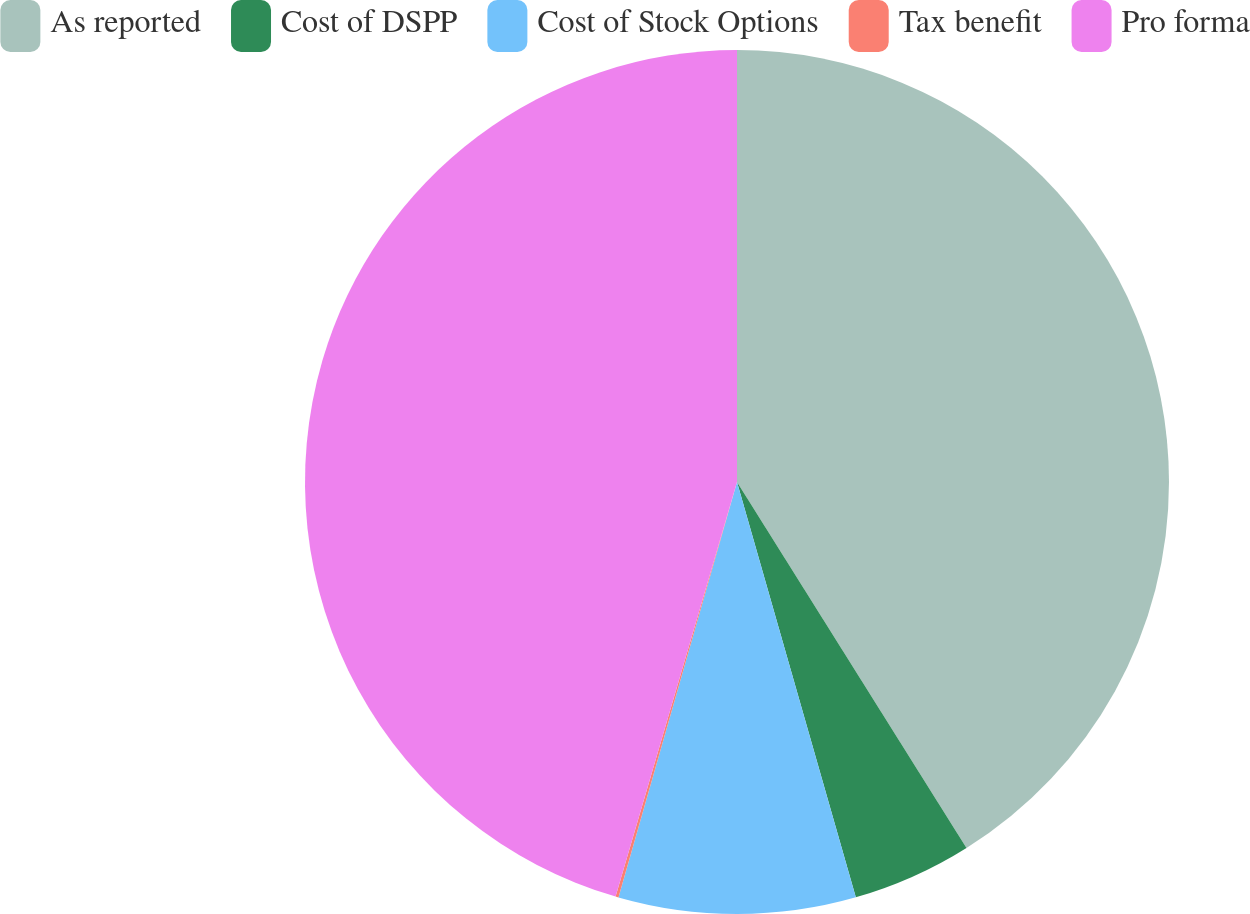Convert chart to OTSL. <chart><loc_0><loc_0><loc_500><loc_500><pie_chart><fcel>As reported<fcel>Cost of DSPP<fcel>Cost of Stock Options<fcel>Tax benefit<fcel>Pro forma<nl><fcel>41.09%<fcel>4.48%<fcel>8.86%<fcel>0.11%<fcel>45.47%<nl></chart> 